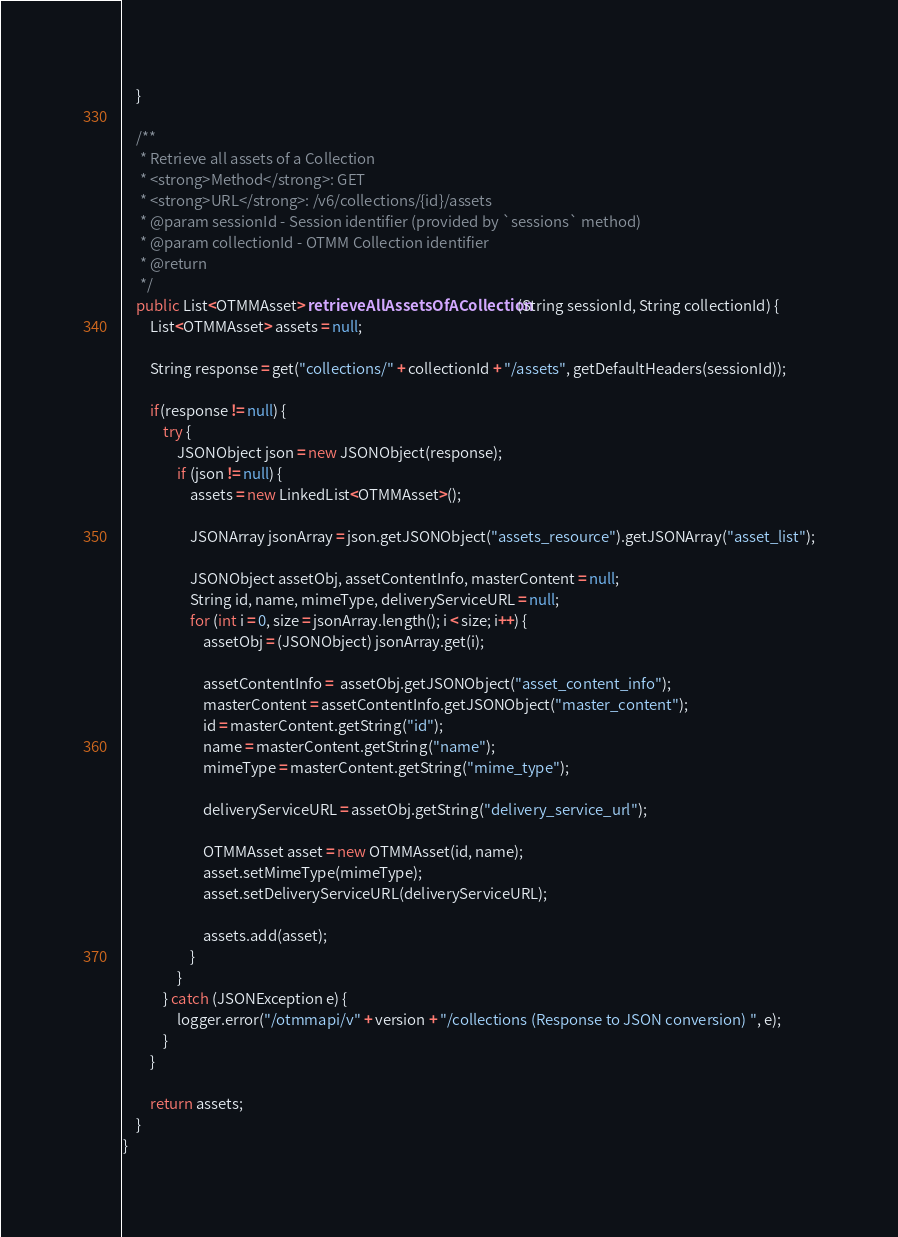<code> <loc_0><loc_0><loc_500><loc_500><_Java_>	}
	
	/**
	 * Retrieve all assets of a Collection
	 * <strong>Method</strong>: GET
	 * <strong>URL</strong>: /v6/collections/{id}/assets
	 * @param sessionId - Session identifier (provided by `sessions` method)
	 * @param collectionId - OTMM Collection identifier
	 * @return
	 */
	public List<OTMMAsset> retrieveAllAssetsOfACollection(String sessionId, String collectionId) {
		List<OTMMAsset> assets = null;
		
		String response = get("collections/" + collectionId + "/assets", getDefaultHeaders(sessionId));
		
		if(response != null) {
			try {
				JSONObject json = new JSONObject(response);
				if (json != null) {
					assets = new LinkedList<OTMMAsset>();
					
					JSONArray jsonArray = json.getJSONObject("assets_resource").getJSONArray("asset_list");
					
					JSONObject assetObj, assetContentInfo, masterContent = null;
					String id, name, mimeType, deliveryServiceURL = null;
				    for (int i = 0, size = jsonArray.length(); i < size; i++) {
				    	assetObj = (JSONObject) jsonArray.get(i);
				    	
				    	assetContentInfo =  assetObj.getJSONObject("asset_content_info");	
				    	masterContent = assetContentInfo.getJSONObject("master_content"); 
				    	id = masterContent.getString("id");
				    	name = masterContent.getString("name");
				    	mimeType = masterContent.getString("mime_type");
				    	
				    	deliveryServiceURL = assetObj.getString("delivery_service_url");
				    	
				    	OTMMAsset asset = new OTMMAsset(id, name);
				    	asset.setMimeType(mimeType);
				    	asset.setDeliveryServiceURL(deliveryServiceURL);
				    	
				    	assets.add(asset);
					}
				}
			} catch (JSONException e) {
				logger.error("/otmmapi/v" + version + "/collections (Response to JSON conversion) ", e);
			}
		}
		
		return assets;
	}
}
</code> 